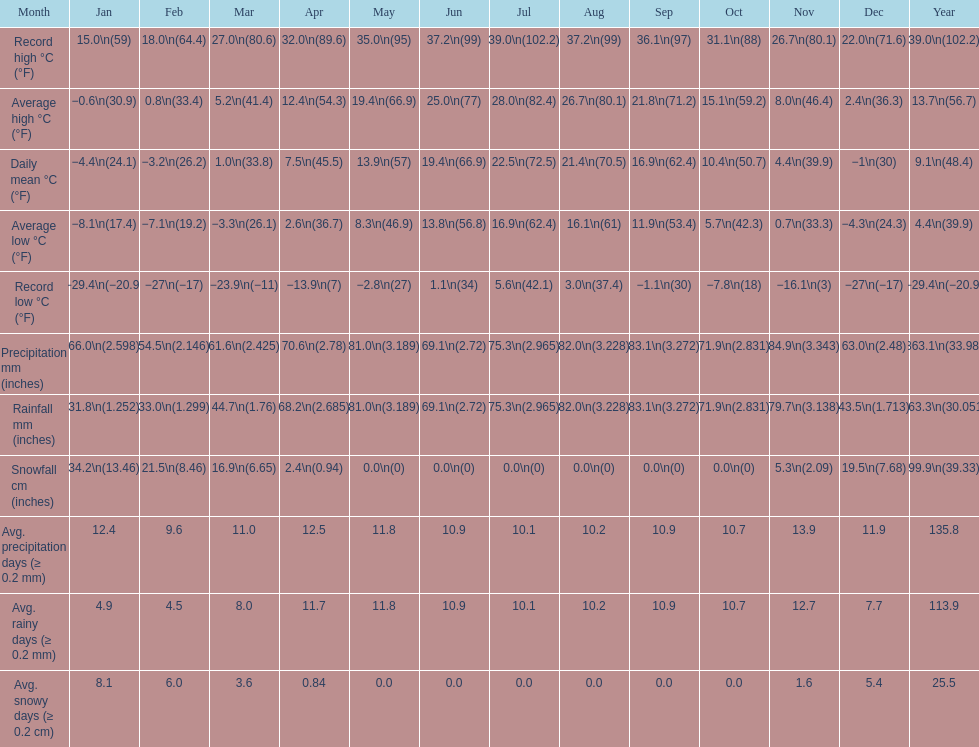0 degrees? 11. 